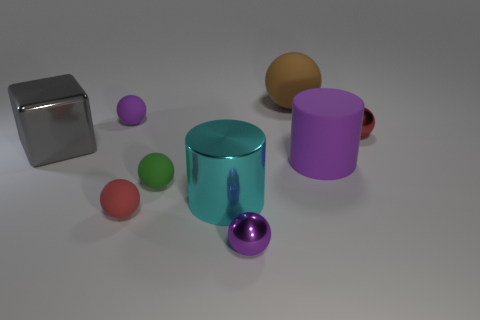Is the number of matte things right of the big cyan cylinder less than the number of purple matte cylinders that are left of the brown sphere?
Your answer should be compact. No. What number of red rubber spheres are there?
Offer a terse response. 1. Are there any other things that are the same material as the tiny green object?
Your response must be concise. Yes. There is a brown object that is the same shape as the green object; what is it made of?
Keep it short and to the point. Rubber. Are there fewer shiny objects behind the small green rubber thing than gray rubber cylinders?
Your answer should be very brief. No. Does the small object that is on the right side of the brown object have the same shape as the green thing?
Make the answer very short. Yes. Are there any other things that have the same color as the big rubber cylinder?
Make the answer very short. Yes. What size is the purple object that is made of the same material as the purple cylinder?
Your answer should be very brief. Small. What is the material of the small purple ball that is right of the small matte thing behind the large matte thing in front of the large gray metallic cube?
Provide a short and direct response. Metal. Are there fewer spheres than purple metal things?
Keep it short and to the point. No. 